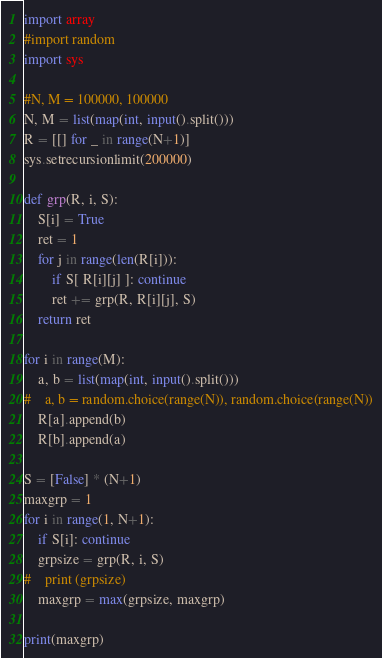Convert code to text. <code><loc_0><loc_0><loc_500><loc_500><_Python_>import array
#import random
import sys

#N, M = 100000, 100000
N, M = list(map(int, input().split()))
R = [[] for _ in range(N+1)]
sys.setrecursionlimit(200000)

def grp(R, i, S):
    S[i] = True
    ret = 1
    for j in range(len(R[i])):
        if S[ R[i][j] ]: continue
        ret += grp(R, R[i][j], S)
    return ret

for i in range(M):
    a, b = list(map(int, input().split()))
#    a, b = random.choice(range(N)), random.choice(range(N))
    R[a].append(b)
    R[b].append(a)

S = [False] * (N+1)
maxgrp = 1
for i in range(1, N+1):
    if S[i]: continue
    grpsize = grp(R, i, S)
#    print (grpsize)
    maxgrp = max(grpsize, maxgrp)

print(maxgrp)
</code> 